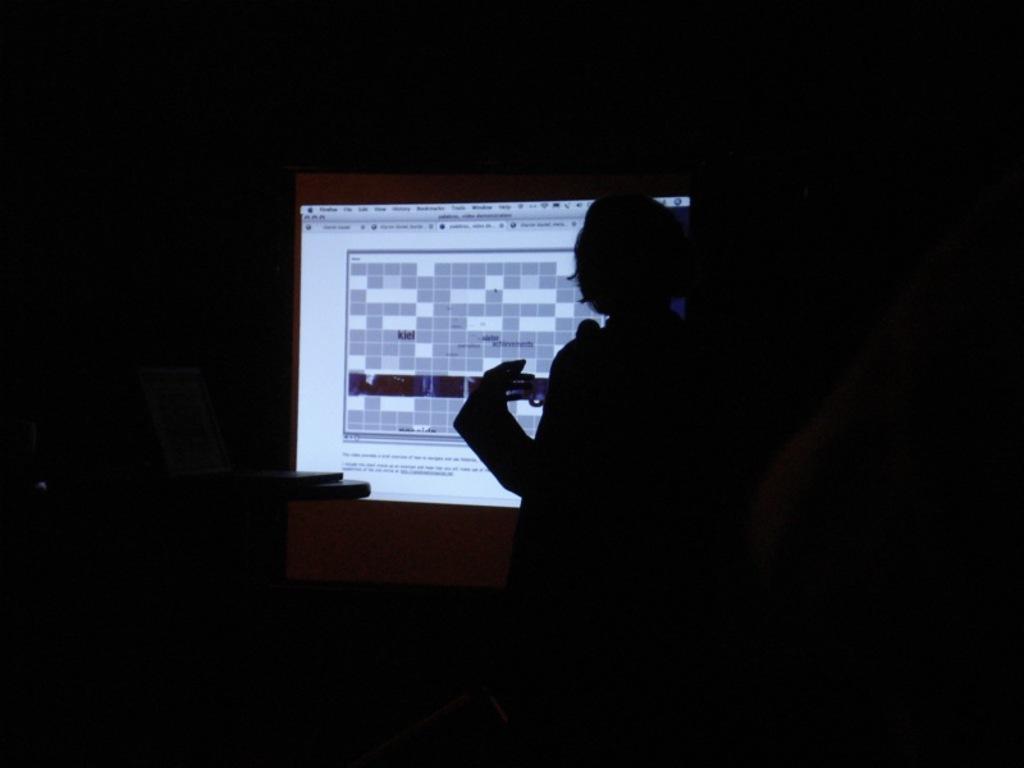Describe this image in one or two sentences. In this image I can see the person in-front of the screen. And there is a black background. 